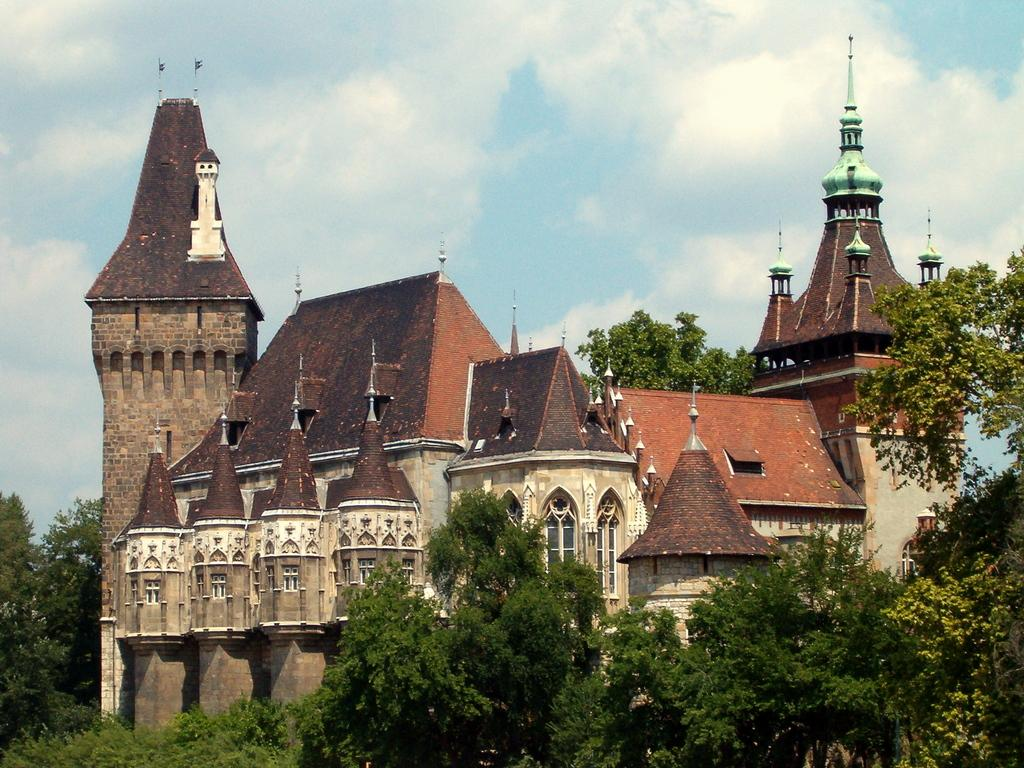What is the main subject of the image? The main subject of the image is a building. Can you describe the building's features? The building has a wall, a roof, pillars, and windows. What can be seen in the surroundings of the building? There are trees and grass in the image. What is visible in the background of the image? The sky is visible in the background of the image, and clouds are present. What type of voice can be heard coming from the building in the image? There is no indication of any sound or voice in the image, as it only shows a building with its features and the surrounding environment. 